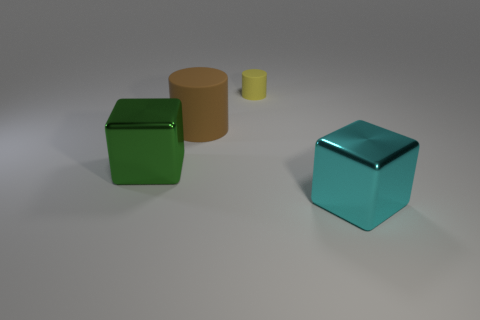There is a matte object right of the large matte cylinder; is its color the same as the cube behind the large cyan block?
Provide a succinct answer. No. There is another matte thing that is the same shape as the yellow thing; what color is it?
Your answer should be very brief. Brown. Is there any other thing that has the same shape as the brown rubber thing?
Your response must be concise. Yes. Do the large metal object in front of the green block and the green thing that is to the left of the small yellow cylinder have the same shape?
Provide a succinct answer. Yes. Do the yellow thing and the metal block to the left of the brown thing have the same size?
Your response must be concise. No. Are there more green blocks than blue metal balls?
Provide a succinct answer. Yes. Is the large brown thing that is to the left of the cyan block made of the same material as the cyan block that is right of the yellow matte cylinder?
Offer a terse response. No. What is the brown object made of?
Provide a succinct answer. Rubber. Is the number of brown objects behind the cyan metal object greater than the number of tiny gray spheres?
Offer a very short reply. Yes. What number of cubes are on the right side of the matte cylinder left of the cylinder that is behind the brown matte object?
Provide a succinct answer. 1. 